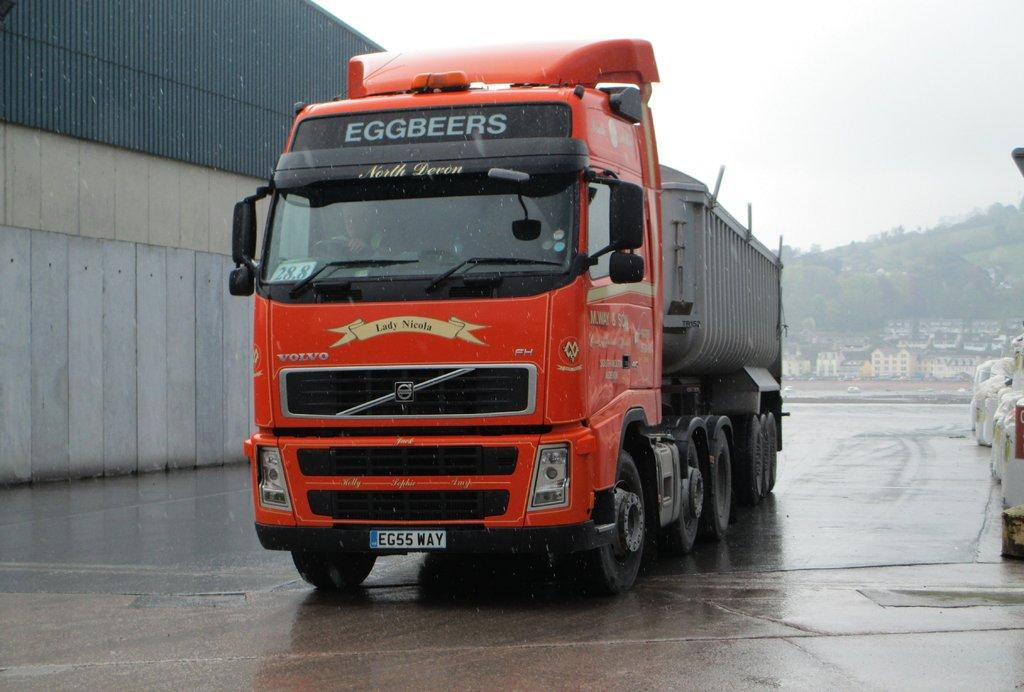What is on the road in the image? There is a vehicle on the road in the image. What can be seen in the image besides the vehicle? There is a wall, trees, buildings, and the sky visible in the image. Can you describe the vegetation in the image? Trees are present in the image. What is visible in the background of the image? The sky is visible in the background of the image. What type of anger can be seen on the trees in the image? There is no anger present in the image, as it features a vehicle on the road, a wall, trees, buildings, and the sky. 